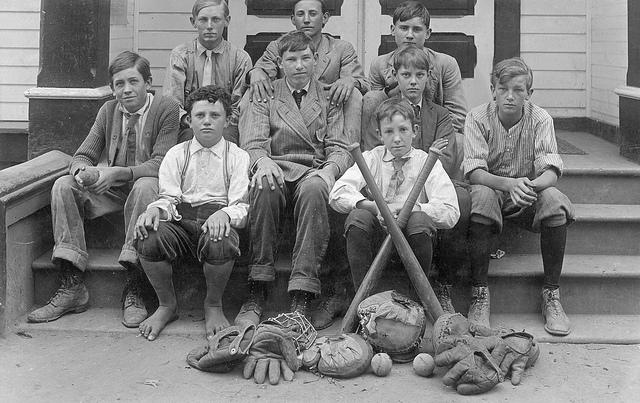Which of the boys is the biggest?
Give a very brief answer. Middle. Is this outdoor?
Quick response, please. Yes. What kind of team are these boys on?
Keep it brief. Baseball. 